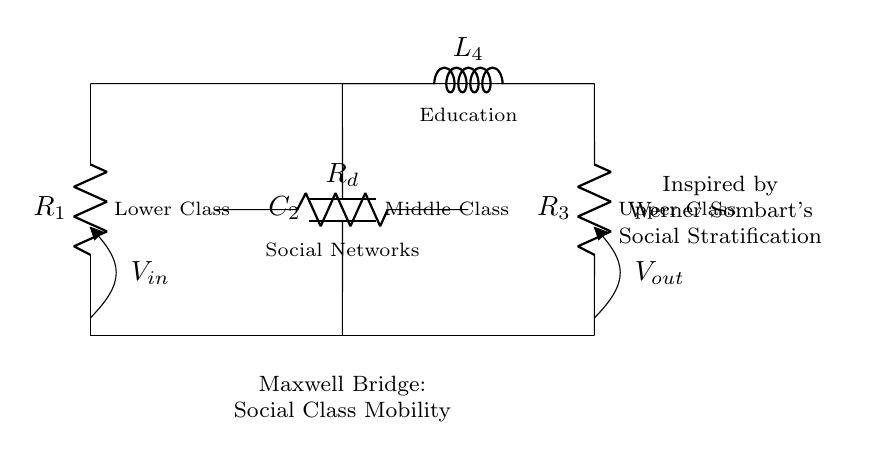What are the three classes represented in the circuit? The three classes represented are Lower Class (R1), Middle Class (C2), and Upper Class (R3). These are explicitly labeled next to their respective components in the diagram.
Answer: Lower Class, Middle Class, Upper Class What does the component labeled C2 represent? The component labeled C2 represents the Middle Class in this social mobility analogy. It's shown as a capacitor in the circuit diagram, linking the concepts of capacitance and middle class fluidity.
Answer: Middle Class Which component signifies the influence of social networks? The component R_d signifies the influence of social networks, as indicated by its label in the circuit diagram. This resistor reflects how connections can impact class mobility.
Answer: Social Networks How are social networks connected to education in this circuit? Social networks (R_d) are connected in parallel to education (L_4), indicating that both play significant roles in influencing class mobility within the framework provided. This parallel connection highlights the simultaneous impact of these factors.
Answer: In parallel What kind of bridge does this circuit represent? This circuit represents a Maxwell Bridge, which is typically used for balancing and measuring impedances. Here, it symbolizes the dynamics of social class mobility through its structure and components.
Answer: Maxwell Bridge What component type is used to represent education in the circuit? The component type used to represent education in this circuit is an inductor (L). Inductors are commonly associated with the accumulation of energy, similar to how education can accumulate knowledge and resources for social mobility.
Answer: Inductor 